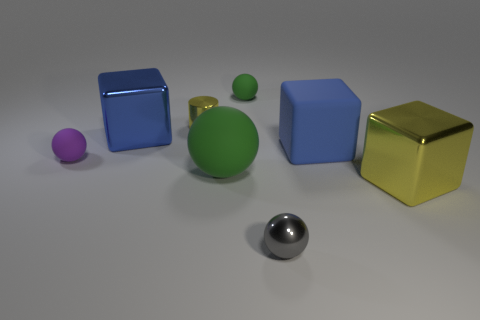There is a thing that is the same color as the big ball; what is its size?
Provide a short and direct response. Small. The big metal thing on the right side of the blue object behind the big blue matte thing is what shape?
Keep it short and to the point. Cube. There is a tiny shiny object on the right side of the large green matte object; is it the same shape as the tiny purple object?
Keep it short and to the point. Yes. There is a purple thing that is the same material as the big green ball; what is its size?
Offer a very short reply. Small. How many objects are either tiny balls that are in front of the tiny yellow thing or tiny green objects left of the big blue rubber thing?
Offer a terse response. 3. Is the number of big yellow metallic cubes that are behind the blue matte object the same as the number of things that are in front of the tiny green matte ball?
Provide a short and direct response. No. What is the color of the big metal block to the left of the small yellow shiny cylinder?
Ensure brevity in your answer.  Blue. There is a tiny shiny cylinder; does it have the same color as the cube that is on the right side of the big blue rubber thing?
Offer a very short reply. Yes. Are there fewer red cubes than objects?
Provide a succinct answer. Yes. There is a tiny rubber ball that is to the right of the tiny purple rubber thing; is its color the same as the big sphere?
Your response must be concise. Yes. 